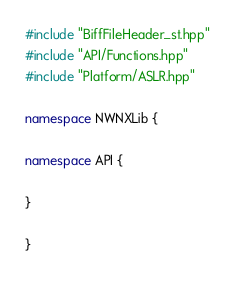<code> <loc_0><loc_0><loc_500><loc_500><_C++_>#include "BiffFileHeader_st.hpp"
#include "API/Functions.hpp"
#include "Platform/ASLR.hpp"

namespace NWNXLib {

namespace API {

}

}
</code> 